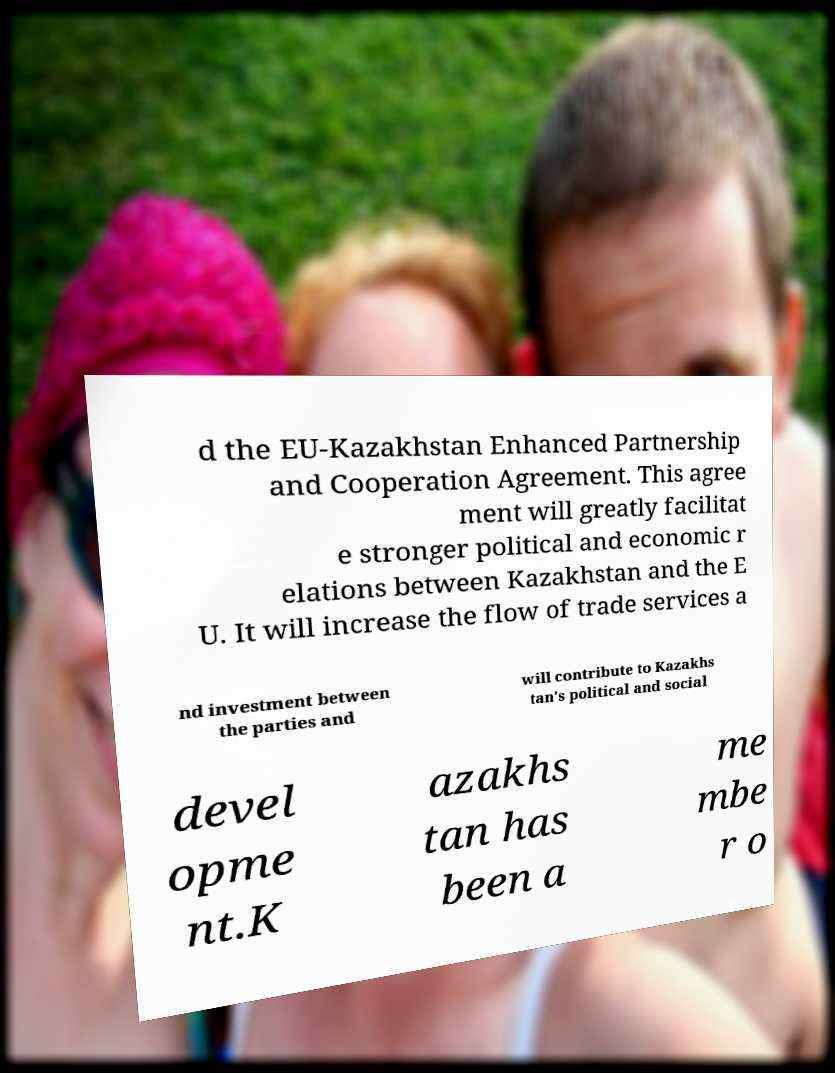I need the written content from this picture converted into text. Can you do that? d the EU-Kazakhstan Enhanced Partnership and Cooperation Agreement. This agree ment will greatly facilitat e stronger political and economic r elations between Kazakhstan and the E U. It will increase the flow of trade services a nd investment between the parties and will contribute to Kazakhs tan's political and social devel opme nt.K azakhs tan has been a me mbe r o 